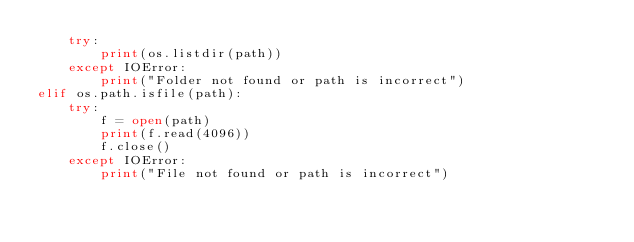Convert code to text. <code><loc_0><loc_0><loc_500><loc_500><_Python_>    try:
        print(os.listdir(path))
    except IOError:
        print("Folder not found or path is incorrect")
elif os.path.isfile(path):
    try:
        f = open(path)
        print(f.read(4096))
        f.close()
    except IOError:
        print("File not found or path is incorrect")
</code> 